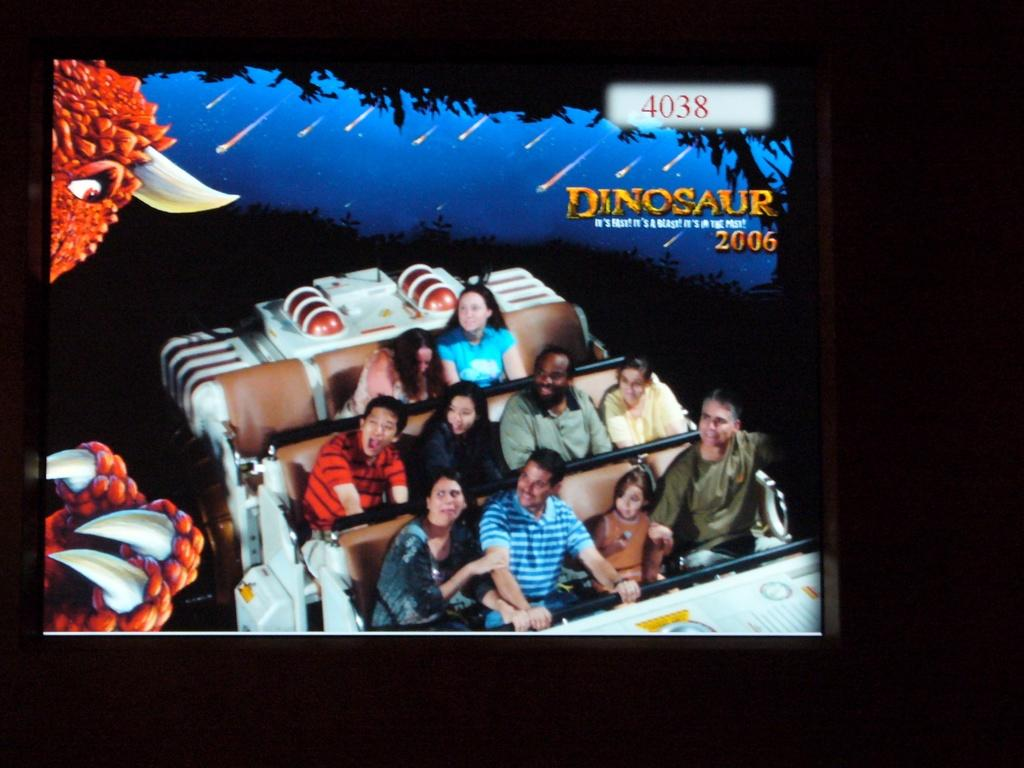<image>
Offer a succinct explanation of the picture presented. A group of people on a theme park ride in 2006. 